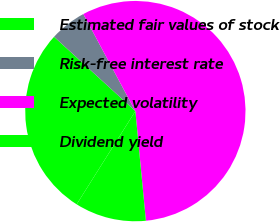<chart> <loc_0><loc_0><loc_500><loc_500><pie_chart><fcel>Estimated fair values of stock<fcel>Risk-free interest rate<fcel>Expected volatility<fcel>Dividend yield<nl><fcel>27.84%<fcel>5.38%<fcel>56.31%<fcel>10.47%<nl></chart> 